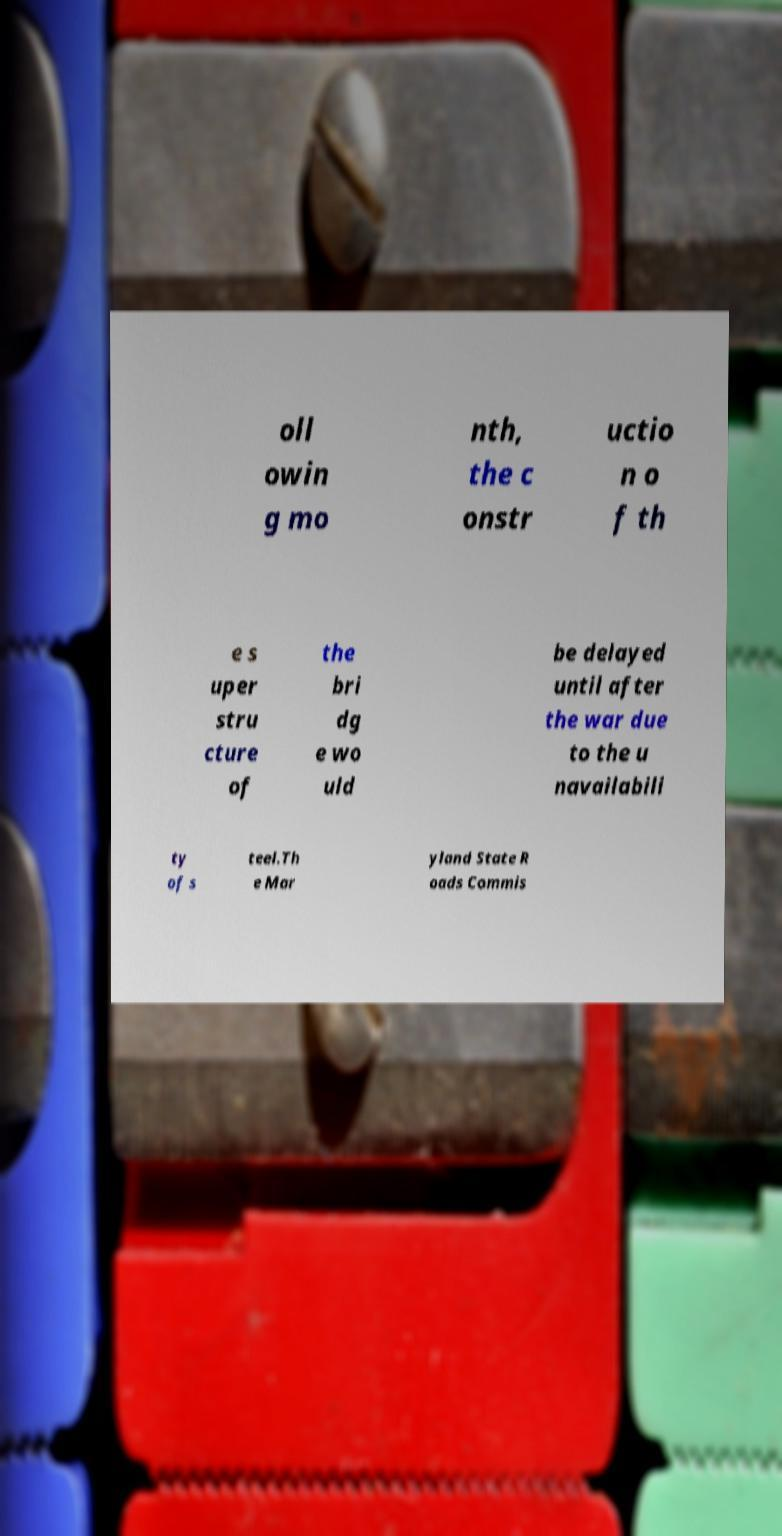Can you accurately transcribe the text from the provided image for me? oll owin g mo nth, the c onstr uctio n o f th e s uper stru cture of the bri dg e wo uld be delayed until after the war due to the u navailabili ty of s teel.Th e Mar yland State R oads Commis 